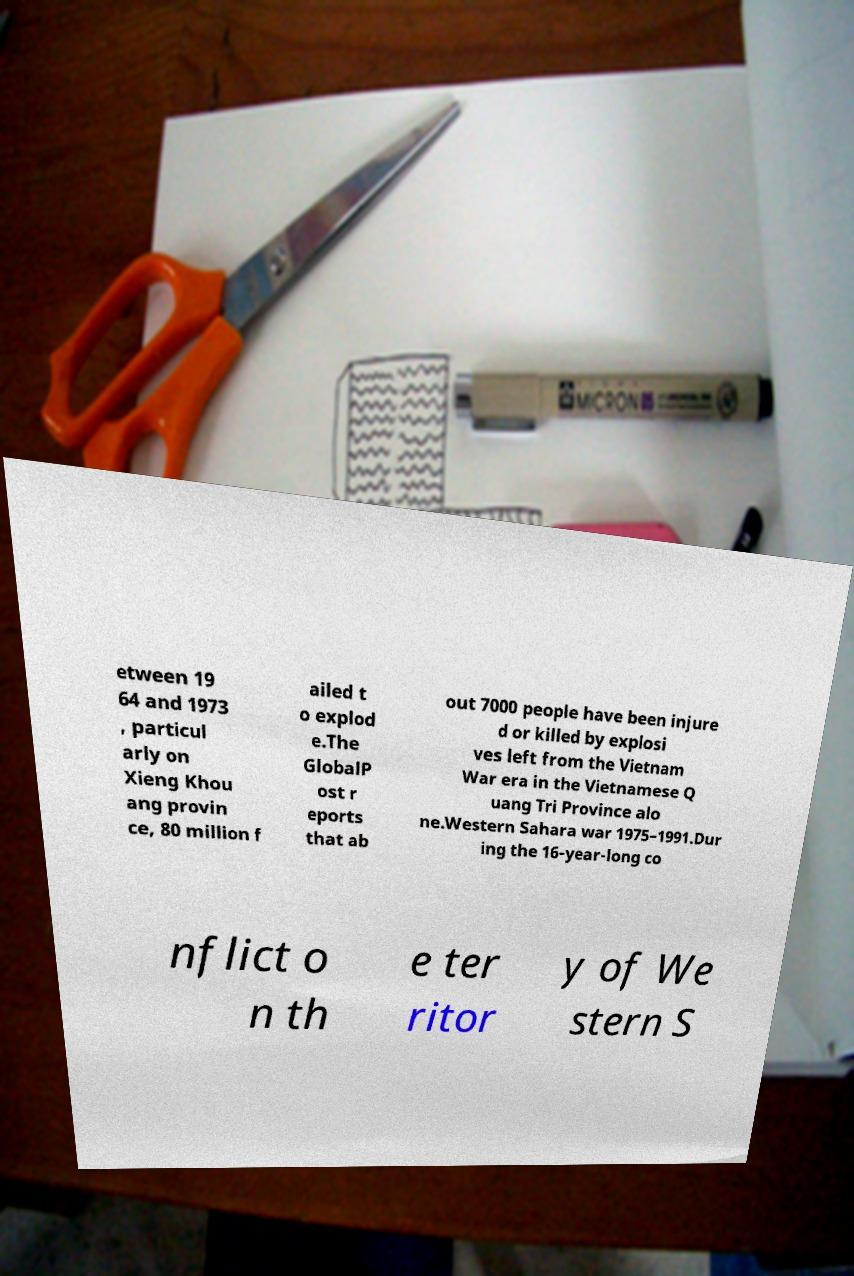Please identify and transcribe the text found in this image. etween 19 64 and 1973 , particul arly on Xieng Khou ang provin ce, 80 million f ailed t o explod e.The GlobalP ost r eports that ab out 7000 people have been injure d or killed by explosi ves left from the Vietnam War era in the Vietnamese Q uang Tri Province alo ne.Western Sahara war 1975–1991.Dur ing the 16-year-long co nflict o n th e ter ritor y of We stern S 